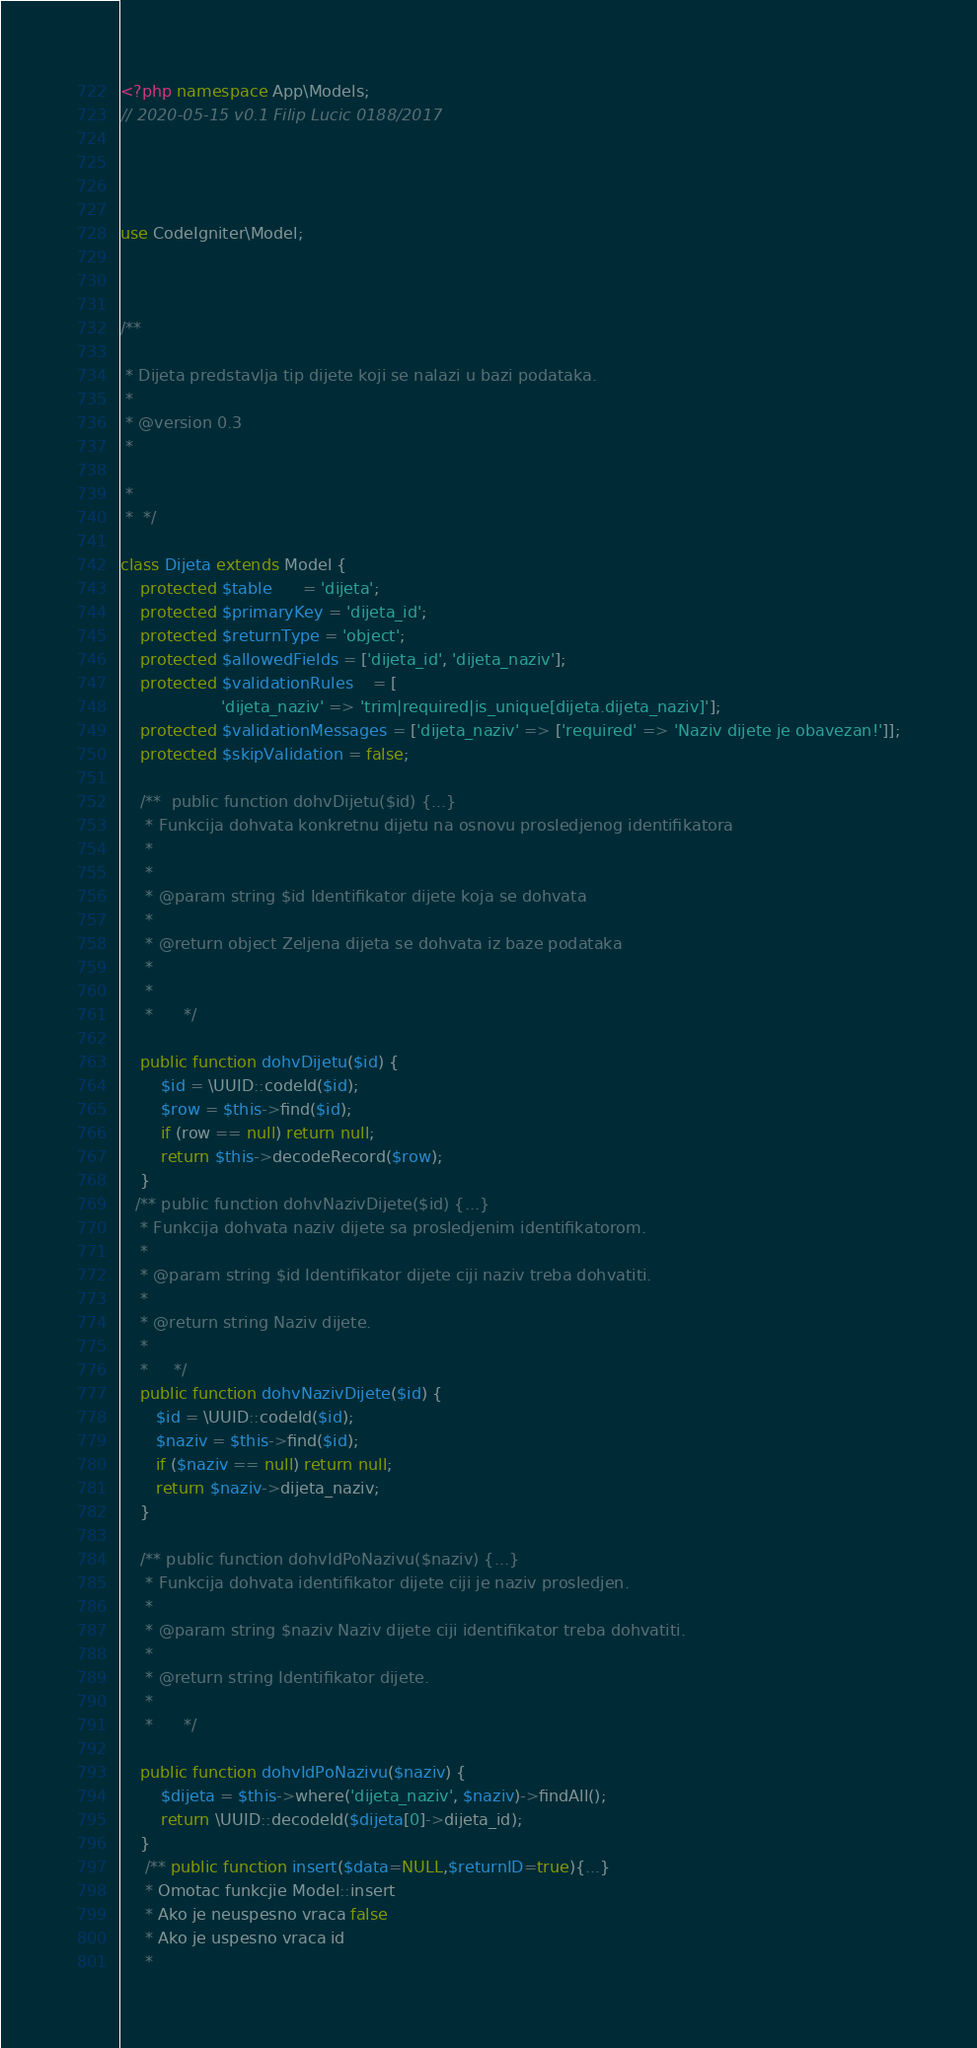<code> <loc_0><loc_0><loc_500><loc_500><_PHP_><?php namespace App\Models;
// 2020-05-15 v0.1 Filip Lucic 0188/2017




use CodeIgniter\Model;



/**
    
 * Dijeta predstavlja tip dijete koji se nalazi u bazi podataka.
 * 
 * @version 0.3
 * 

 * 
 *  */

class Dijeta extends Model {
    protected $table      = 'dijeta';
    protected $primaryKey = 'dijeta_id';
    protected $returnType = 'object';
    protected $allowedFields = ['dijeta_id', 'dijeta_naziv']; 
    protected $validationRules    = [
                    'dijeta_naziv' => 'trim|required|is_unique[dijeta.dijeta_naziv]'];
    protected $validationMessages = ['dijeta_naziv' => ['required' => 'Naziv dijete je obavezan!']];
    protected $skipValidation = false;
    
    /**  public function dohvDijetu($id) {...}
     * Funkcija dohvata konkretnu dijetu na osnovu prosledjenog identifikatora
     * 
     * 
     * @param string $id Identifikator dijete koja se dohvata
     * 
     * @return object Zeljena dijeta se dohvata iz baze podataka
     * 
     * 
     *      */
    
    public function dohvDijetu($id) {
        $id = \UUID::codeId($id);
        $row = $this->find($id);
        if (row == null) return null;
        return $this->decodeRecord($row);
    }
   /** public function dohvNazivDijete($id) {...}
    * Funkcija dohvata naziv dijete sa prosledjenim identifikatorom.
    * 
    * @param string $id Identifikator dijete ciji naziv treba dohvatiti.
    * 
    * @return string Naziv dijete.
    * 
    *     */
    public function dohvNazivDijete($id) {
       $id = \UUID::codeId($id);
       $naziv = $this->find($id);
       if ($naziv == null) return null;
       return $naziv->dijeta_naziv;
    }
    
    /** public function dohvIdPoNazivu($naziv) {...}
     * Funkcija dohvata identifikator dijete ciji je naziv prosledjen.
     * 
     * @param string $naziv Naziv dijete ciji identifikator treba dohvatiti.
     * 
     * @return string Identifikator dijete.
     * 
     *      */

    public function dohvIdPoNazivu($naziv) {
        $dijeta = $this->where('dijeta_naziv', $naziv)->findAll();
        return \UUID::decodeId($dijeta[0]->dijeta_id);
    }
     /** public function insert($data=NULL,$returnID=true){...}
     * Omotac funkcjie Model::insert
     * Ako je neuspesno vraca false
     * Ako je uspesno vraca id
     * </code> 